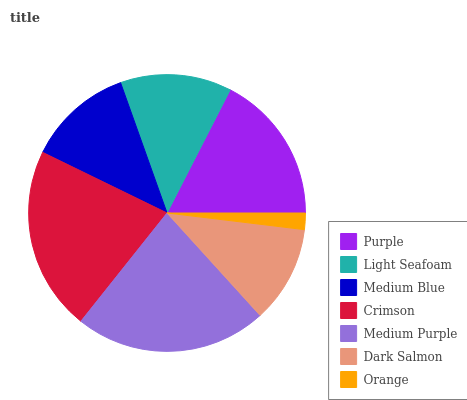Is Orange the minimum?
Answer yes or no. Yes. Is Medium Purple the maximum?
Answer yes or no. Yes. Is Light Seafoam the minimum?
Answer yes or no. No. Is Light Seafoam the maximum?
Answer yes or no. No. Is Purple greater than Light Seafoam?
Answer yes or no. Yes. Is Light Seafoam less than Purple?
Answer yes or no. Yes. Is Light Seafoam greater than Purple?
Answer yes or no. No. Is Purple less than Light Seafoam?
Answer yes or no. No. Is Light Seafoam the high median?
Answer yes or no. Yes. Is Light Seafoam the low median?
Answer yes or no. Yes. Is Purple the high median?
Answer yes or no. No. Is Purple the low median?
Answer yes or no. No. 